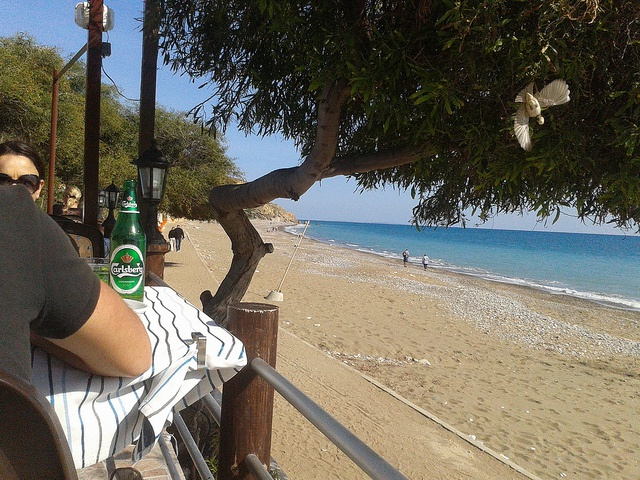Describe the objects in this image and their specific colors. I can see people in lightblue, black, and tan tones, dining table in lightblue, white, gray, darkgray, and black tones, chair in lightblue, black, gray, and maroon tones, bottle in lightblue, darkgreen, black, gray, and lightgray tones, and bird in lightblue, black, gray, and olive tones in this image. 